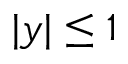Convert formula to latex. <formula><loc_0><loc_0><loc_500><loc_500>| y | \leq 1</formula> 